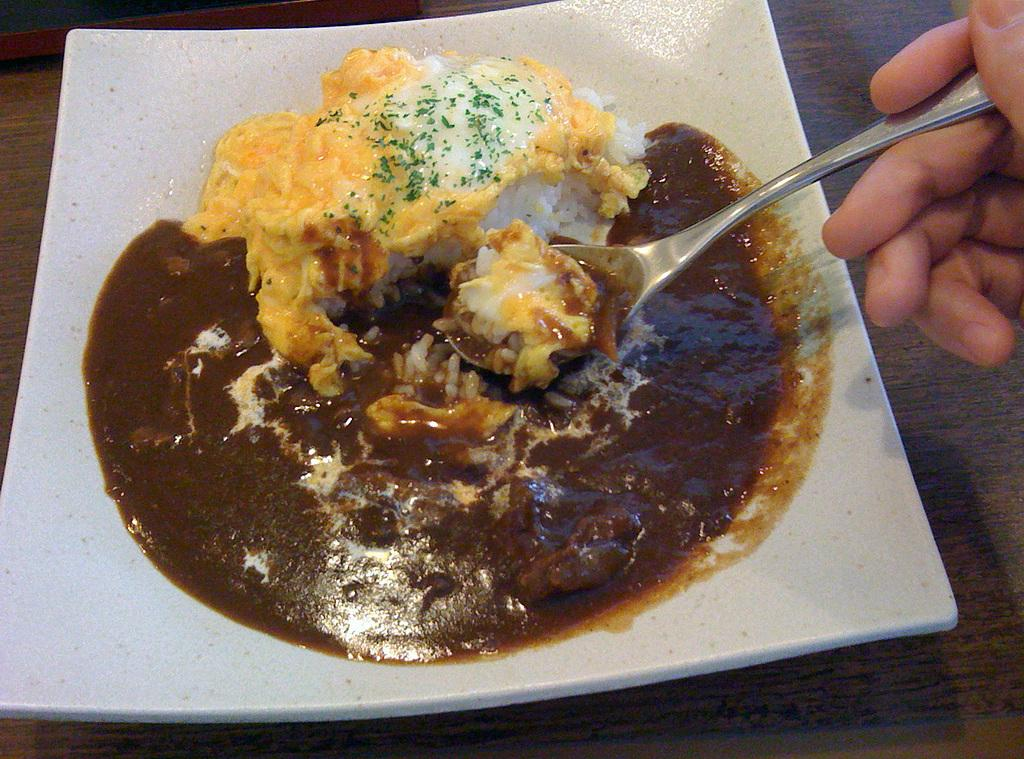What is on the plate in the image? There is food in a plate in the image. Who is holding the spoon in the image? There is a person holding a spoon in the image. Where is the spoon located in relation to the image? The spoon is at the right side of the image. What is the object below the plate made of? The wooden object below the plate in the image is made of wood. What is the title of the book that the dolls are reading in the image? There are no dolls or books present in the image, so there is no title to mention. 